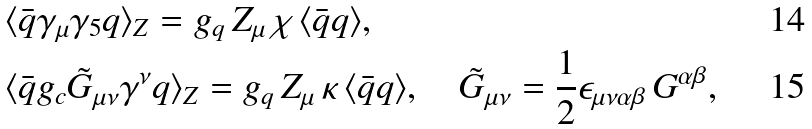Convert formula to latex. <formula><loc_0><loc_0><loc_500><loc_500>& \langle \bar { q } \gamma _ { \mu } \gamma _ { 5 } q \rangle _ { Z } = g _ { q } \, Z _ { \mu } \, \chi \, \langle \bar { q } q \rangle , \\ & \langle \bar { q } g _ { c } \tilde { G } _ { \mu \nu } \gamma ^ { \nu } q \rangle _ { Z } = g _ { q } \, Z _ { \mu } \, \kappa \, \langle \bar { q } q \rangle , \quad \tilde { G } _ { \mu \nu } = \frac { 1 } { 2 } \epsilon _ { \mu \nu \alpha \beta } \, G ^ { \alpha \beta } ,</formula> 